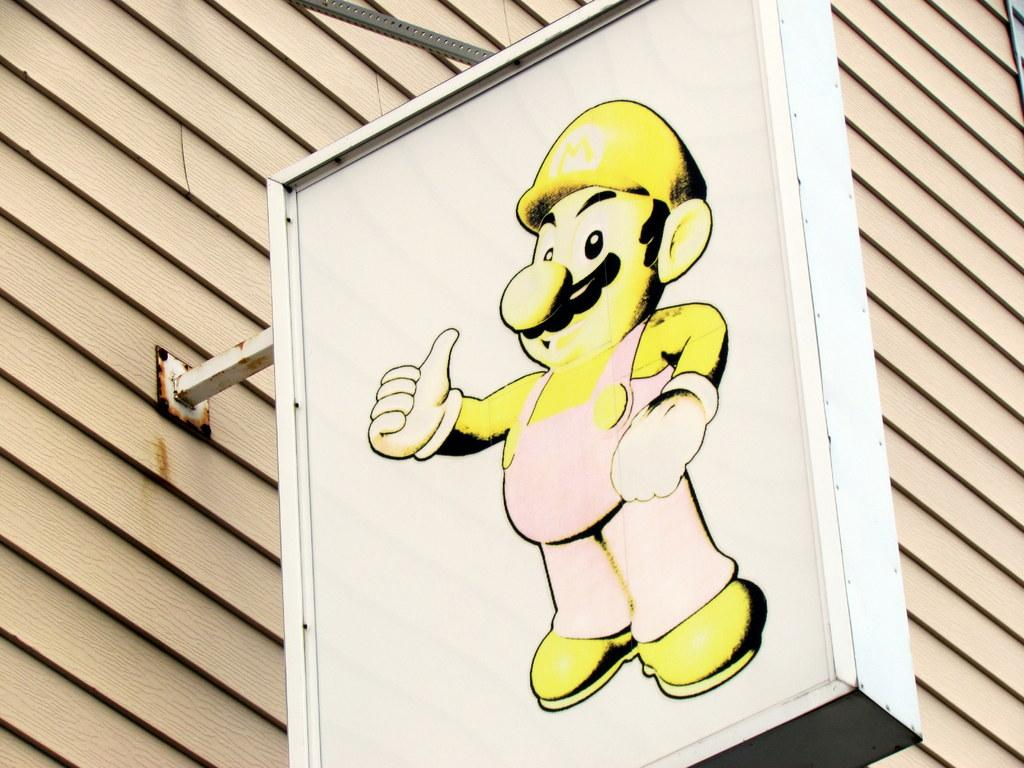What is attached to the board in the image? There is a poster on a board in the image. What type of material is the wall made of? The wall visible in the image is made of wood. What flavor of wrench can be seen on the wooden wall in the image? There is no wrench present in the image, and therefore no flavor can be associated with it. 